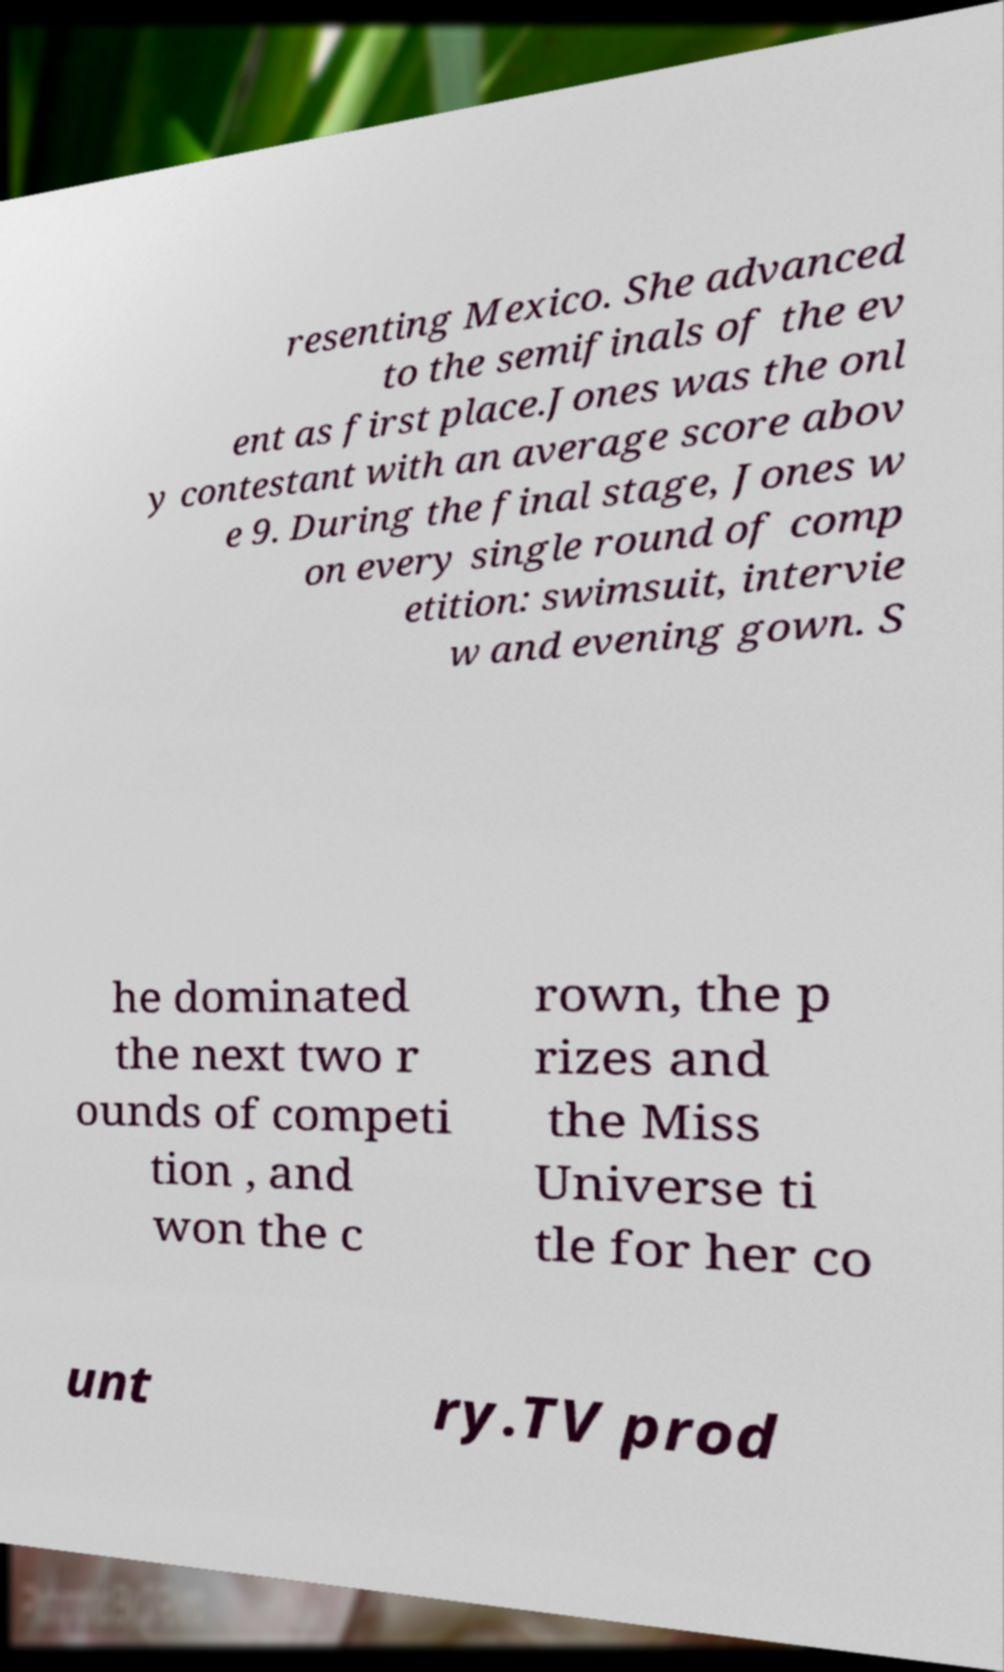I need the written content from this picture converted into text. Can you do that? resenting Mexico. She advanced to the semifinals of the ev ent as first place.Jones was the onl y contestant with an average score abov e 9. During the final stage, Jones w on every single round of comp etition: swimsuit, intervie w and evening gown. S he dominated the next two r ounds of competi tion , and won the c rown, the p rizes and the Miss Universe ti tle for her co unt ry.TV prod 